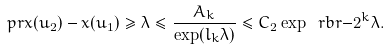<formula> <loc_0><loc_0><loc_500><loc_500>\ p r { x ( u _ { 2 } ) - x ( u _ { 1 } ) \geq \lambda } \leq \frac { A _ { k } } { \exp ( l _ { k } \lambda ) } \leq C _ { 2 } \exp \ r b r { - 2 ^ { k } \lambda } .</formula> 